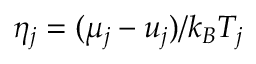Convert formula to latex. <formula><loc_0><loc_0><loc_500><loc_500>\eta _ { j } = ( { \mu _ { j } } - u _ { j } ) / k _ { B } T _ { j }</formula> 